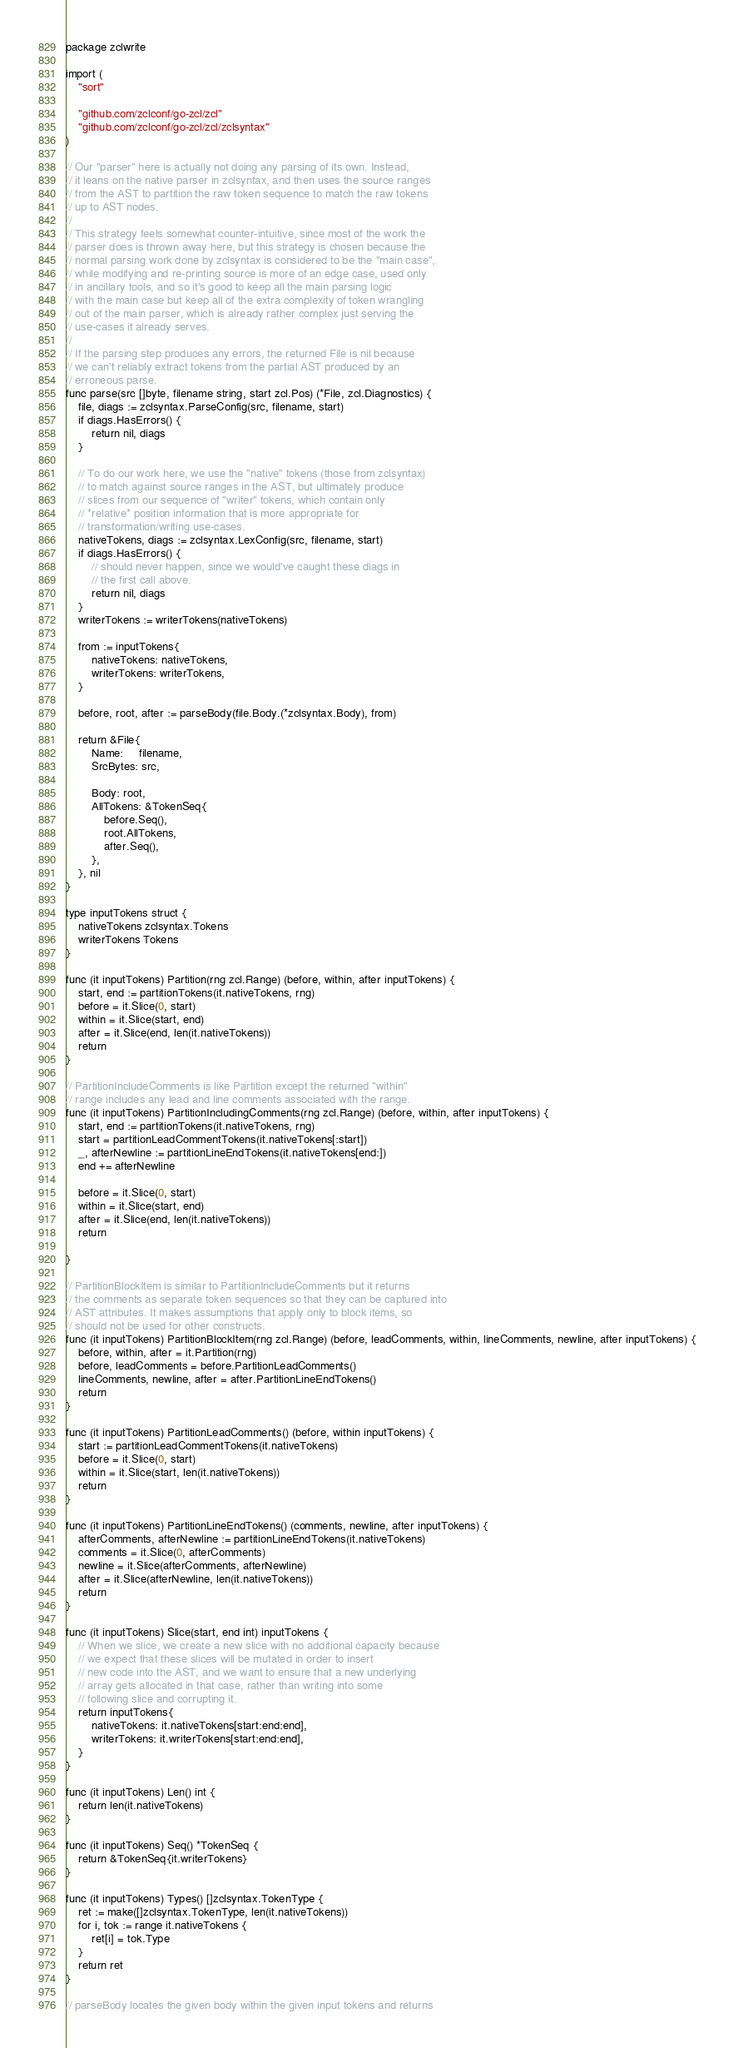Convert code to text. <code><loc_0><loc_0><loc_500><loc_500><_Go_>package zclwrite

import (
	"sort"

	"github.com/zclconf/go-zcl/zcl"
	"github.com/zclconf/go-zcl/zcl/zclsyntax"
)

// Our "parser" here is actually not doing any parsing of its own. Instead,
// it leans on the native parser in zclsyntax, and then uses the source ranges
// from the AST to partition the raw token sequence to match the raw tokens
// up to AST nodes.
//
// This strategy feels somewhat counter-intuitive, since most of the work the
// parser does is thrown away here, but this strategy is chosen because the
// normal parsing work done by zclsyntax is considered to be the "main case",
// while modifying and re-printing source is more of an edge case, used only
// in ancillary tools, and so it's good to keep all the main parsing logic
// with the main case but keep all of the extra complexity of token wrangling
// out of the main parser, which is already rather complex just serving the
// use-cases it already serves.
//
// If the parsing step produces any errors, the returned File is nil because
// we can't reliably extract tokens from the partial AST produced by an
// erroneous parse.
func parse(src []byte, filename string, start zcl.Pos) (*File, zcl.Diagnostics) {
	file, diags := zclsyntax.ParseConfig(src, filename, start)
	if diags.HasErrors() {
		return nil, diags
	}

	// To do our work here, we use the "native" tokens (those from zclsyntax)
	// to match against source ranges in the AST, but ultimately produce
	// slices from our sequence of "writer" tokens, which contain only
	// *relative* position information that is more appropriate for
	// transformation/writing use-cases.
	nativeTokens, diags := zclsyntax.LexConfig(src, filename, start)
	if diags.HasErrors() {
		// should never happen, since we would've caught these diags in
		// the first call above.
		return nil, diags
	}
	writerTokens := writerTokens(nativeTokens)

	from := inputTokens{
		nativeTokens: nativeTokens,
		writerTokens: writerTokens,
	}

	before, root, after := parseBody(file.Body.(*zclsyntax.Body), from)

	return &File{
		Name:     filename,
		SrcBytes: src,

		Body: root,
		AllTokens: &TokenSeq{
			before.Seq(),
			root.AllTokens,
			after.Seq(),
		},
	}, nil
}

type inputTokens struct {
	nativeTokens zclsyntax.Tokens
	writerTokens Tokens
}

func (it inputTokens) Partition(rng zcl.Range) (before, within, after inputTokens) {
	start, end := partitionTokens(it.nativeTokens, rng)
	before = it.Slice(0, start)
	within = it.Slice(start, end)
	after = it.Slice(end, len(it.nativeTokens))
	return
}

// PartitionIncludeComments is like Partition except the returned "within"
// range includes any lead and line comments associated with the range.
func (it inputTokens) PartitionIncludingComments(rng zcl.Range) (before, within, after inputTokens) {
	start, end := partitionTokens(it.nativeTokens, rng)
	start = partitionLeadCommentTokens(it.nativeTokens[:start])
	_, afterNewline := partitionLineEndTokens(it.nativeTokens[end:])
	end += afterNewline

	before = it.Slice(0, start)
	within = it.Slice(start, end)
	after = it.Slice(end, len(it.nativeTokens))
	return

}

// PartitionBlockItem is similar to PartitionIncludeComments but it returns
// the comments as separate token sequences so that they can be captured into
// AST attributes. It makes assumptions that apply only to block items, so
// should not be used for other constructs.
func (it inputTokens) PartitionBlockItem(rng zcl.Range) (before, leadComments, within, lineComments, newline, after inputTokens) {
	before, within, after = it.Partition(rng)
	before, leadComments = before.PartitionLeadComments()
	lineComments, newline, after = after.PartitionLineEndTokens()
	return
}

func (it inputTokens) PartitionLeadComments() (before, within inputTokens) {
	start := partitionLeadCommentTokens(it.nativeTokens)
	before = it.Slice(0, start)
	within = it.Slice(start, len(it.nativeTokens))
	return
}

func (it inputTokens) PartitionLineEndTokens() (comments, newline, after inputTokens) {
	afterComments, afterNewline := partitionLineEndTokens(it.nativeTokens)
	comments = it.Slice(0, afterComments)
	newline = it.Slice(afterComments, afterNewline)
	after = it.Slice(afterNewline, len(it.nativeTokens))
	return
}

func (it inputTokens) Slice(start, end int) inputTokens {
	// When we slice, we create a new slice with no additional capacity because
	// we expect that these slices will be mutated in order to insert
	// new code into the AST, and we want to ensure that a new underlying
	// array gets allocated in that case, rather than writing into some
	// following slice and corrupting it.
	return inputTokens{
		nativeTokens: it.nativeTokens[start:end:end],
		writerTokens: it.writerTokens[start:end:end],
	}
}

func (it inputTokens) Len() int {
	return len(it.nativeTokens)
}

func (it inputTokens) Seq() *TokenSeq {
	return &TokenSeq{it.writerTokens}
}

func (it inputTokens) Types() []zclsyntax.TokenType {
	ret := make([]zclsyntax.TokenType, len(it.nativeTokens))
	for i, tok := range it.nativeTokens {
		ret[i] = tok.Type
	}
	return ret
}

// parseBody locates the given body within the given input tokens and returns</code> 